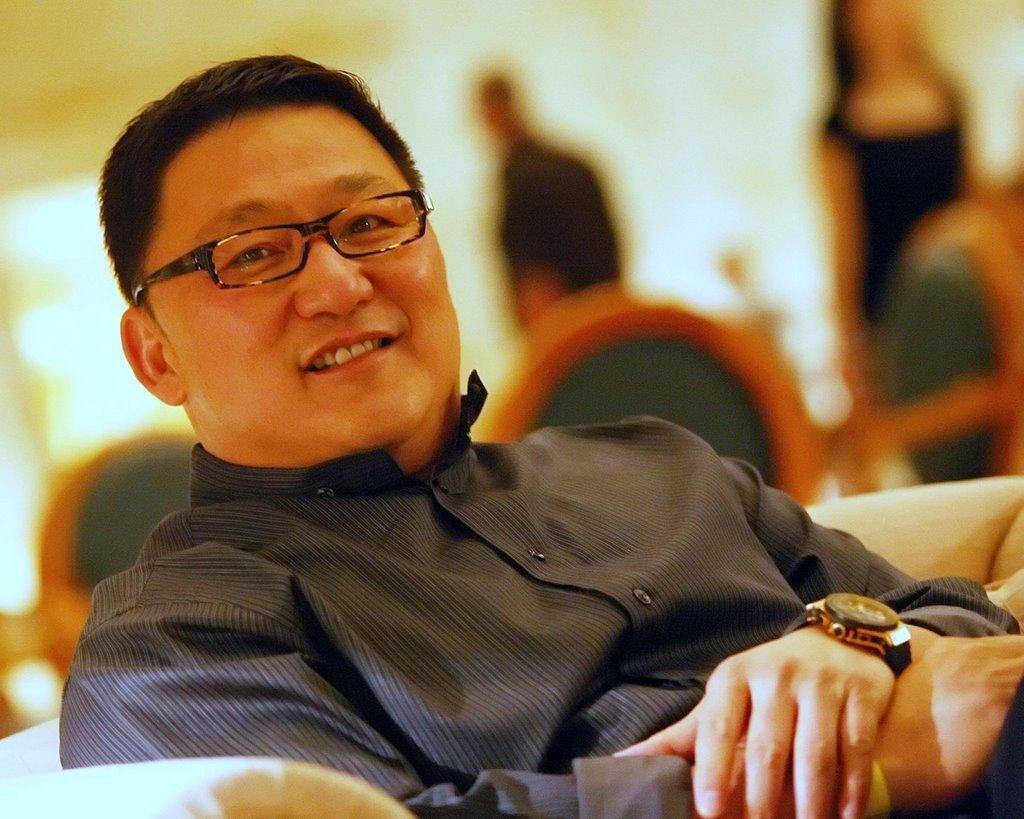What is the man in the image doing? The man is sitting in the image. What is the man wearing on his upper body? The man is wearing a shirt. What accessory is the man wearing on his face? The man is wearing glasses. What accessory is the man wearing on his wrist? The man is wearing a watch. How would you describe the background of the image? The background of the image is blurry. What type of amusement can be seen in the man participating in the image? There is no amusement activity present in the image; the man is simply sitting. Is there a show happening in the background of the image? There is no show or any indication of a performance in the image; the background is blurry. 